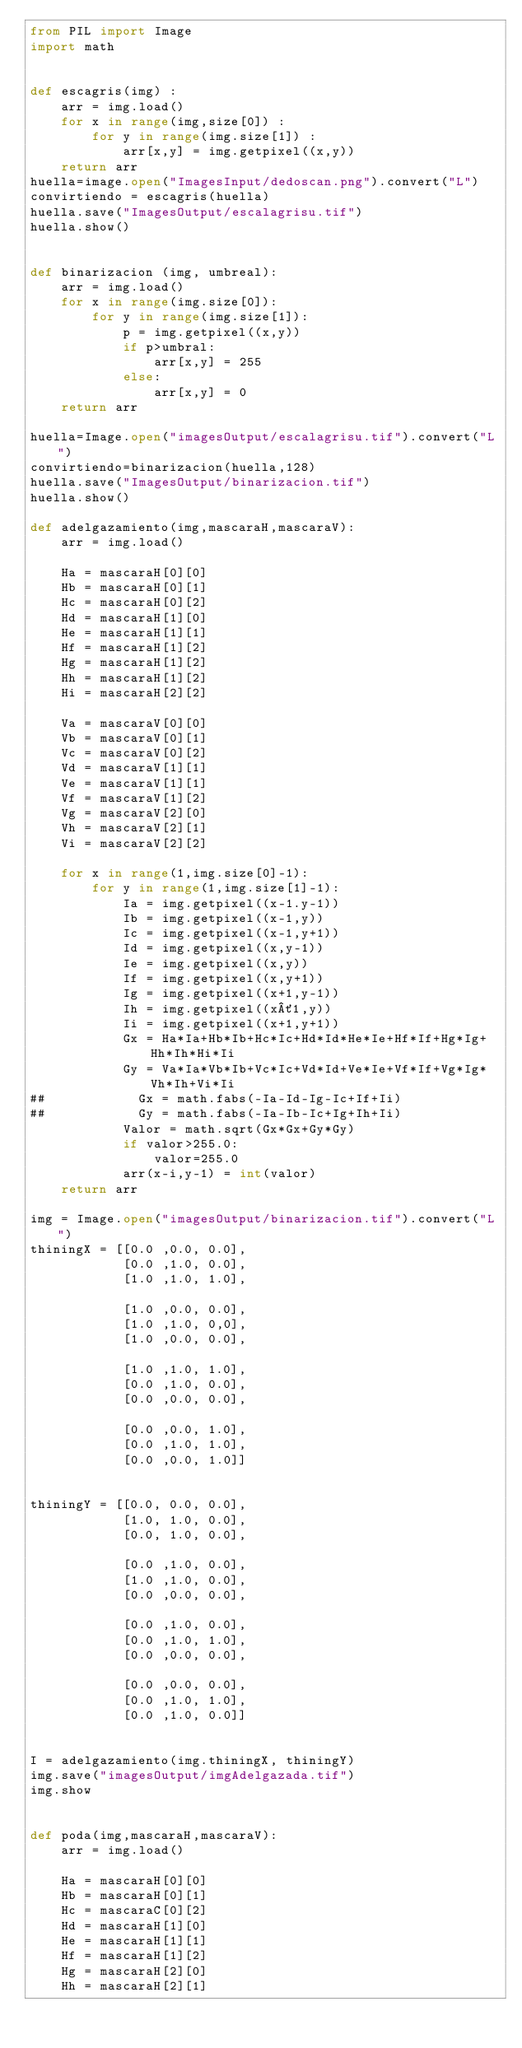<code> <loc_0><loc_0><loc_500><loc_500><_Python_>from PIL import Image
import math


def escagris(img) :
    arr = img.load()
    for x in range(img,size[0]) :
        for y in range(img.size[1]) :
            arr[x,y] = img.getpixel((x,y))
    return arr
huella=image.open("ImagesInput/dedoscan.png").convert("L")
convirtiendo = escagris(huella)
huella.save("ImagesOutput/escalagrisu.tif")
huella.show()


def binarizacion (img, umbreal):
    arr = img.load()
    for x in range(img.size[0]):
        for y in range(img.size[1]):
            p = img.getpixel((x,y))
            if p>umbral:
                arr[x,y] = 255
            else:
                arr[x,y] = 0
    return arr

huella=Image.open("imagesOutput/escalagrisu.tif").convert("L")
convirtiendo=binarizacion(huella,128)
huella.save("ImagesOutput/binarizacion.tif")
huella.show()

def adelgazamiento(img,mascaraH,mascaraV):
    arr = img.load()

    Ha = mascaraH[0][0]
    Hb = mascaraH[0][1]
    Hc = mascaraH[0][2]
    Hd = mascaraH[1][0]
    He = mascaraH[1][1]
    Hf = mascaraH[1][2]
    Hg = mascaraH[1][2]
    Hh = mascaraH[1][2]
    Hi = mascaraH[2][2]

    Va = mascaraV[0][0]
    Vb = mascaraV[0][1]
    Vc = mascaraV[0][2]
    Vd = mascaraV[1][1]
    Ve = mascaraV[1][1]
    Vf = mascaraV[1][2]
    Vg = mascaraV[2][0]
    Vh = mascaraV[2][1]
    Vi = mascaraV[2][2]

    for x in range(1,img.size[0]-1):
        for y in range(1,img.size[1]-1):
            Ia = img.getpixel((x-1.y-1))
            Ib = img.getpixel((x-1,y))
            Ic = img.getpixel((x-1,y+1))
            Id = img.getpixel((x,y-1))
            Ie = img.getpixel((x,y))
            If = img.getpixel((x,y+1))
            Ig = img.getpixel((x+1,y-1))
            Ih = img.getpixel((x´1,y))
            Ii = img.getpixel((x+1,y+1))
            Gx = Ha*Ia+Hb*Ib+Hc*Ic+Hd*Id*He*Ie+Hf*If+Hg*Ig+Hh*Ih*Hi*Ii
            Gy = Va*Ia*Vb*Ib+Vc*Ic+Vd*Id+Ve*Ie+Vf*If+Vg*Ig*Vh*Ih+Vi*Ii
##            Gx = math.fabs(-Ia-Id-Ig-Ic+If+Ii)
##            Gy = math.fabs(-Ia-Ib-Ic+Ig+Ih+Ii)
            Valor = math.sqrt(Gx*Gx+Gy*Gy)
            if valor>255.0:
                valor=255.0
            arr(x-i,y-1) = int(valor)
    return arr

img = Image.open("imagesOutput/binarizacion.tif").convert("L")
thiningX = [[0.0 ,0.0, 0.0],
            [0.0 ,1.0, 0.0],
            [1.0 ,1.0, 1.0],

            [1.0 ,0.0, 0.0],
            [1.0 ,1.0, 0,0],
            [1.0 ,0.0, 0.0],

            [1.0 ,1.0, 1.0],
            [0.0 ,1.0, 0.0],
            [0.0 ,0.0, 0.0],

            [0.0 ,0.0, 1.0],
            [0.0 ,1.0, 1.0],
            [0.0 ,0.0, 1.0]]


thiningY = [[0.0, 0.0, 0.0],
            [1.0, 1.0, 0.0],
            [0.0, 1.0, 0.0],

            [0.0 ,1.0, 0.0],
            [1.0 ,1.0, 0.0],
            [0.0 ,0.0, 0.0],

            [0.0 ,1.0, 0.0],
            [0.0 ,1.0, 1.0],
            [0.0 ,0.0, 0.0],

            [0.0 ,0.0, 0.0],
            [0.0 ,1.0, 1.0],
            [0.0 ,1.0, 0.0]]


I = adelgazamiento(img.thiningX, thiningY)
img.save("imagesOutput/imgAdelgazada.tif")
img.show


def poda(img,mascaraH,mascaraV):
    arr = img.load()

    Ha = mascaraH[0][0]
    Hb = mascaraH[0][1]
    Hc = mascaraC[0][2]
    Hd = mascaraH[1][0]
    He = mascaraH[1][1]
    Hf = mascaraH[1][2]
    Hg = mascaraH[2][0]
    Hh = mascaraH[2][1]</code> 